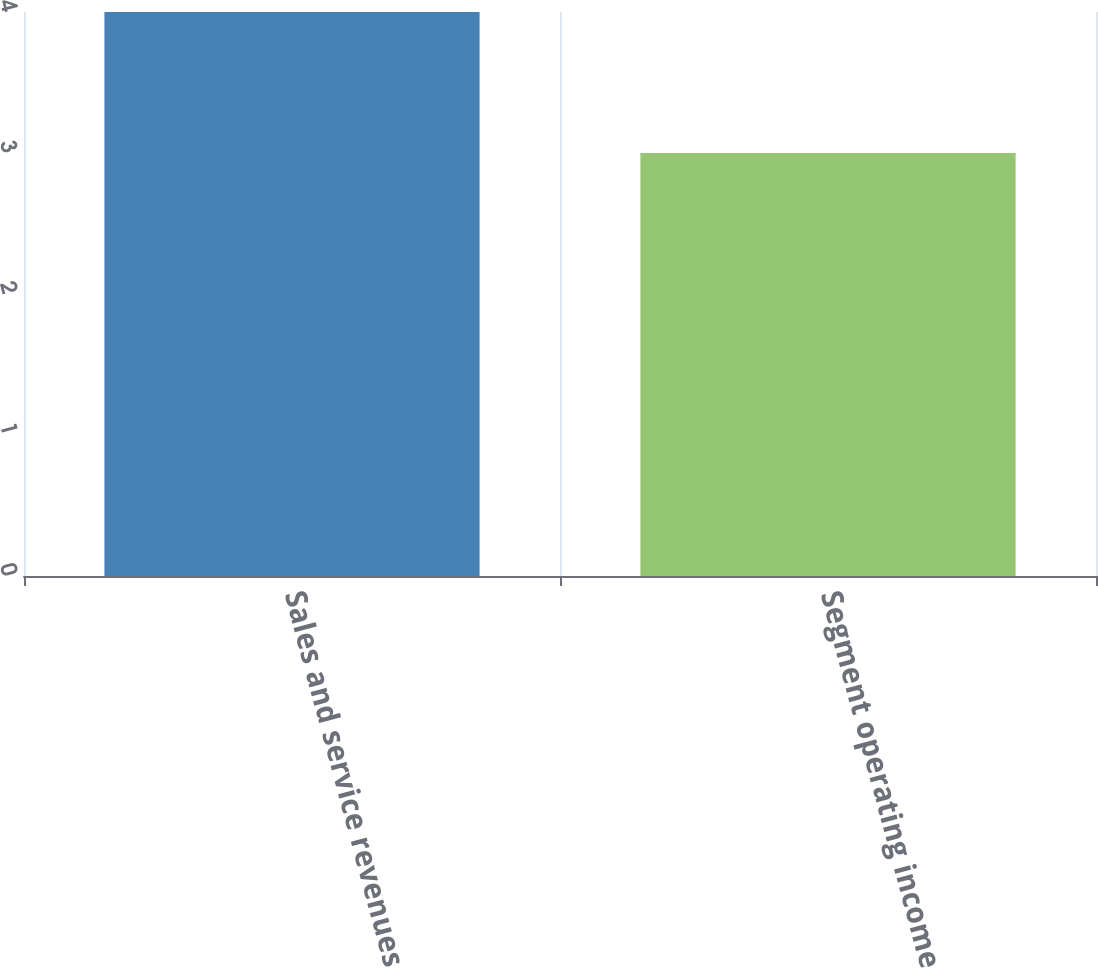Convert chart to OTSL. <chart><loc_0><loc_0><loc_500><loc_500><bar_chart><fcel>Sales and service revenues<fcel>Segment operating income<nl><fcel>4<fcel>3<nl></chart> 